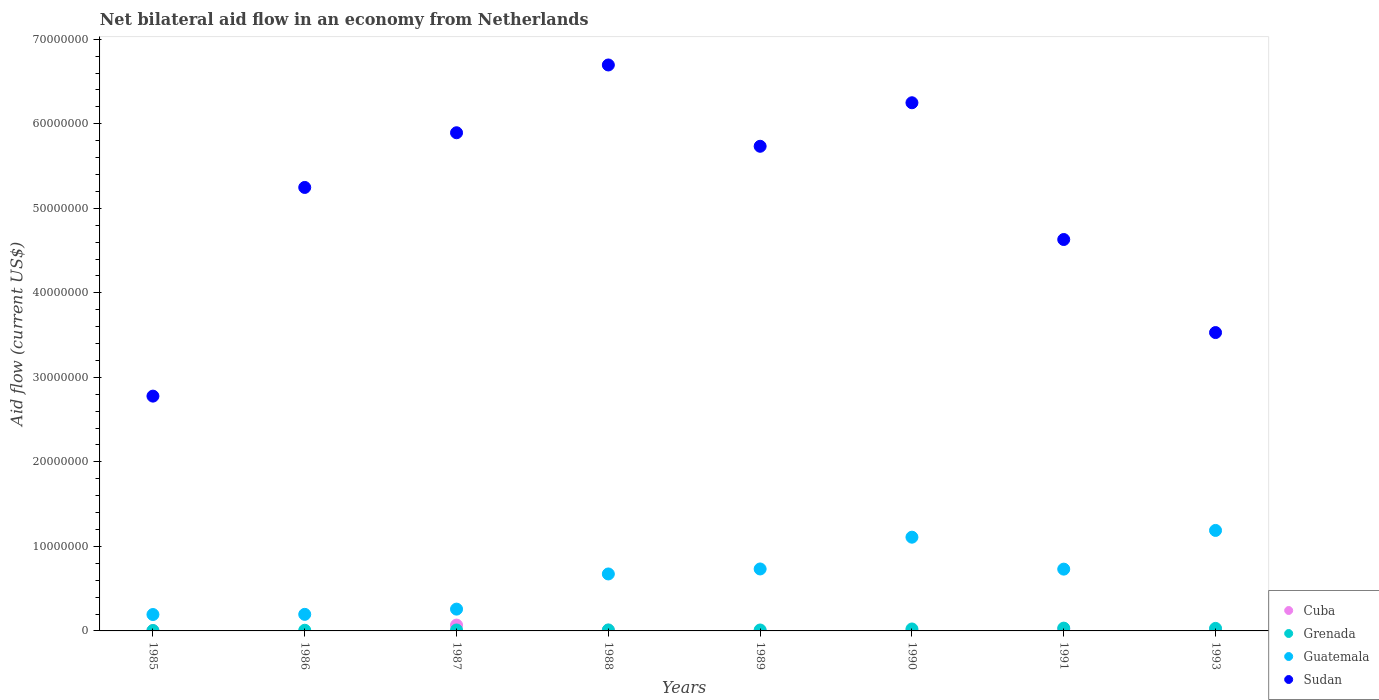How many different coloured dotlines are there?
Give a very brief answer. 4. Is the number of dotlines equal to the number of legend labels?
Give a very brief answer. No. What is the net bilateral aid flow in Guatemala in 1986?
Your answer should be compact. 1.96e+06. Across all years, what is the maximum net bilateral aid flow in Sudan?
Your answer should be very brief. 6.70e+07. What is the total net bilateral aid flow in Grenada in the graph?
Ensure brevity in your answer.  1.33e+06. What is the difference between the net bilateral aid flow in Cuba in 1985 and that in 1987?
Offer a terse response. -6.60e+05. What is the difference between the net bilateral aid flow in Sudan in 1993 and the net bilateral aid flow in Guatemala in 1986?
Offer a very short reply. 3.33e+07. What is the average net bilateral aid flow in Grenada per year?
Your response must be concise. 1.66e+05. In the year 1991, what is the difference between the net bilateral aid flow in Guatemala and net bilateral aid flow in Grenada?
Keep it short and to the point. 6.98e+06. In how many years, is the net bilateral aid flow in Sudan greater than 22000000 US$?
Provide a short and direct response. 8. What is the ratio of the net bilateral aid flow in Guatemala in 1985 to that in 1987?
Offer a terse response. 0.75. What is the difference between the highest and the second highest net bilateral aid flow in Cuba?
Make the answer very short. 4.70e+05. What is the difference between the highest and the lowest net bilateral aid flow in Guatemala?
Give a very brief answer. 9.95e+06. In how many years, is the net bilateral aid flow in Cuba greater than the average net bilateral aid flow in Cuba taken over all years?
Your response must be concise. 2. Is the net bilateral aid flow in Guatemala strictly greater than the net bilateral aid flow in Cuba over the years?
Provide a short and direct response. Yes. How many dotlines are there?
Offer a terse response. 4. What is the difference between two consecutive major ticks on the Y-axis?
Provide a short and direct response. 1.00e+07. Where does the legend appear in the graph?
Provide a short and direct response. Bottom right. What is the title of the graph?
Provide a succinct answer. Net bilateral aid flow in an economy from Netherlands. What is the Aid flow (current US$) of Grenada in 1985?
Your answer should be very brief. 5.00e+04. What is the Aid flow (current US$) of Guatemala in 1985?
Your response must be concise. 1.94e+06. What is the Aid flow (current US$) of Sudan in 1985?
Provide a short and direct response. 2.78e+07. What is the Aid flow (current US$) in Guatemala in 1986?
Your answer should be compact. 1.96e+06. What is the Aid flow (current US$) in Sudan in 1986?
Your answer should be very brief. 5.25e+07. What is the Aid flow (current US$) in Cuba in 1987?
Offer a very short reply. 6.90e+05. What is the Aid flow (current US$) of Guatemala in 1987?
Give a very brief answer. 2.58e+06. What is the Aid flow (current US$) in Sudan in 1987?
Offer a terse response. 5.89e+07. What is the Aid flow (current US$) of Cuba in 1988?
Give a very brief answer. 8.00e+04. What is the Aid flow (current US$) of Grenada in 1988?
Offer a very short reply. 1.20e+05. What is the Aid flow (current US$) of Guatemala in 1988?
Provide a succinct answer. 6.74e+06. What is the Aid flow (current US$) of Sudan in 1988?
Your answer should be compact. 6.70e+07. What is the Aid flow (current US$) of Guatemala in 1989?
Ensure brevity in your answer.  7.33e+06. What is the Aid flow (current US$) in Sudan in 1989?
Your answer should be compact. 5.73e+07. What is the Aid flow (current US$) in Grenada in 1990?
Provide a short and direct response. 2.30e+05. What is the Aid flow (current US$) in Guatemala in 1990?
Keep it short and to the point. 1.11e+07. What is the Aid flow (current US$) of Sudan in 1990?
Offer a terse response. 6.25e+07. What is the Aid flow (current US$) in Cuba in 1991?
Offer a very short reply. 2.20e+05. What is the Aid flow (current US$) in Grenada in 1991?
Make the answer very short. 3.30e+05. What is the Aid flow (current US$) in Guatemala in 1991?
Your response must be concise. 7.31e+06. What is the Aid flow (current US$) in Sudan in 1991?
Provide a succinct answer. 4.63e+07. What is the Aid flow (current US$) of Cuba in 1993?
Give a very brief answer. 1.10e+05. What is the Aid flow (current US$) in Grenada in 1993?
Give a very brief answer. 3.00e+05. What is the Aid flow (current US$) in Guatemala in 1993?
Provide a succinct answer. 1.19e+07. What is the Aid flow (current US$) in Sudan in 1993?
Provide a short and direct response. 3.53e+07. Across all years, what is the maximum Aid flow (current US$) of Cuba?
Make the answer very short. 6.90e+05. Across all years, what is the maximum Aid flow (current US$) in Guatemala?
Provide a short and direct response. 1.19e+07. Across all years, what is the maximum Aid flow (current US$) in Sudan?
Offer a very short reply. 6.70e+07. Across all years, what is the minimum Aid flow (current US$) of Guatemala?
Give a very brief answer. 1.94e+06. Across all years, what is the minimum Aid flow (current US$) of Sudan?
Offer a terse response. 2.78e+07. What is the total Aid flow (current US$) in Cuba in the graph?
Make the answer very short. 1.16e+06. What is the total Aid flow (current US$) in Grenada in the graph?
Give a very brief answer. 1.33e+06. What is the total Aid flow (current US$) in Guatemala in the graph?
Provide a succinct answer. 5.08e+07. What is the total Aid flow (current US$) of Sudan in the graph?
Your response must be concise. 4.08e+08. What is the difference between the Aid flow (current US$) in Grenada in 1985 and that in 1986?
Your answer should be very brief. -3.00e+04. What is the difference between the Aid flow (current US$) of Guatemala in 1985 and that in 1986?
Your answer should be compact. -2.00e+04. What is the difference between the Aid flow (current US$) of Sudan in 1985 and that in 1986?
Give a very brief answer. -2.47e+07. What is the difference between the Aid flow (current US$) of Cuba in 1985 and that in 1987?
Your response must be concise. -6.60e+05. What is the difference between the Aid flow (current US$) of Grenada in 1985 and that in 1987?
Provide a succinct answer. -6.00e+04. What is the difference between the Aid flow (current US$) in Guatemala in 1985 and that in 1987?
Give a very brief answer. -6.40e+05. What is the difference between the Aid flow (current US$) in Sudan in 1985 and that in 1987?
Your response must be concise. -3.12e+07. What is the difference between the Aid flow (current US$) of Cuba in 1985 and that in 1988?
Ensure brevity in your answer.  -5.00e+04. What is the difference between the Aid flow (current US$) in Guatemala in 1985 and that in 1988?
Keep it short and to the point. -4.80e+06. What is the difference between the Aid flow (current US$) in Sudan in 1985 and that in 1988?
Give a very brief answer. -3.92e+07. What is the difference between the Aid flow (current US$) in Guatemala in 1985 and that in 1989?
Your answer should be compact. -5.39e+06. What is the difference between the Aid flow (current US$) in Sudan in 1985 and that in 1989?
Keep it short and to the point. -2.96e+07. What is the difference between the Aid flow (current US$) of Cuba in 1985 and that in 1990?
Your answer should be very brief. 2.00e+04. What is the difference between the Aid flow (current US$) in Guatemala in 1985 and that in 1990?
Keep it short and to the point. -9.15e+06. What is the difference between the Aid flow (current US$) of Sudan in 1985 and that in 1990?
Provide a succinct answer. -3.47e+07. What is the difference between the Aid flow (current US$) of Cuba in 1985 and that in 1991?
Make the answer very short. -1.90e+05. What is the difference between the Aid flow (current US$) of Grenada in 1985 and that in 1991?
Offer a very short reply. -2.80e+05. What is the difference between the Aid flow (current US$) in Guatemala in 1985 and that in 1991?
Offer a terse response. -5.37e+06. What is the difference between the Aid flow (current US$) of Sudan in 1985 and that in 1991?
Your answer should be very brief. -1.85e+07. What is the difference between the Aid flow (current US$) of Cuba in 1985 and that in 1993?
Make the answer very short. -8.00e+04. What is the difference between the Aid flow (current US$) of Guatemala in 1985 and that in 1993?
Give a very brief answer. -9.95e+06. What is the difference between the Aid flow (current US$) in Sudan in 1985 and that in 1993?
Ensure brevity in your answer.  -7.52e+06. What is the difference between the Aid flow (current US$) in Guatemala in 1986 and that in 1987?
Give a very brief answer. -6.20e+05. What is the difference between the Aid flow (current US$) of Sudan in 1986 and that in 1987?
Offer a terse response. -6.47e+06. What is the difference between the Aid flow (current US$) of Guatemala in 1986 and that in 1988?
Offer a terse response. -4.78e+06. What is the difference between the Aid flow (current US$) in Sudan in 1986 and that in 1988?
Make the answer very short. -1.45e+07. What is the difference between the Aid flow (current US$) of Grenada in 1986 and that in 1989?
Give a very brief answer. -3.00e+04. What is the difference between the Aid flow (current US$) in Guatemala in 1986 and that in 1989?
Your response must be concise. -5.37e+06. What is the difference between the Aid flow (current US$) of Sudan in 1986 and that in 1989?
Your response must be concise. -4.87e+06. What is the difference between the Aid flow (current US$) of Guatemala in 1986 and that in 1990?
Keep it short and to the point. -9.13e+06. What is the difference between the Aid flow (current US$) in Sudan in 1986 and that in 1990?
Offer a very short reply. -1.00e+07. What is the difference between the Aid flow (current US$) of Guatemala in 1986 and that in 1991?
Make the answer very short. -5.35e+06. What is the difference between the Aid flow (current US$) in Sudan in 1986 and that in 1991?
Offer a terse response. 6.16e+06. What is the difference between the Aid flow (current US$) in Grenada in 1986 and that in 1993?
Your answer should be compact. -2.20e+05. What is the difference between the Aid flow (current US$) of Guatemala in 1986 and that in 1993?
Your answer should be compact. -9.93e+06. What is the difference between the Aid flow (current US$) in Sudan in 1986 and that in 1993?
Provide a succinct answer. 1.72e+07. What is the difference between the Aid flow (current US$) of Cuba in 1987 and that in 1988?
Offer a very short reply. 6.10e+05. What is the difference between the Aid flow (current US$) of Grenada in 1987 and that in 1988?
Offer a terse response. -10000. What is the difference between the Aid flow (current US$) in Guatemala in 1987 and that in 1988?
Ensure brevity in your answer.  -4.16e+06. What is the difference between the Aid flow (current US$) in Sudan in 1987 and that in 1988?
Your answer should be compact. -8.02e+06. What is the difference between the Aid flow (current US$) of Cuba in 1987 and that in 1989?
Your answer should be compact. 6.70e+05. What is the difference between the Aid flow (current US$) in Guatemala in 1987 and that in 1989?
Provide a short and direct response. -4.75e+06. What is the difference between the Aid flow (current US$) of Sudan in 1987 and that in 1989?
Offer a very short reply. 1.60e+06. What is the difference between the Aid flow (current US$) in Cuba in 1987 and that in 1990?
Offer a terse response. 6.80e+05. What is the difference between the Aid flow (current US$) in Grenada in 1987 and that in 1990?
Offer a very short reply. -1.20e+05. What is the difference between the Aid flow (current US$) of Guatemala in 1987 and that in 1990?
Keep it short and to the point. -8.51e+06. What is the difference between the Aid flow (current US$) of Sudan in 1987 and that in 1990?
Offer a very short reply. -3.55e+06. What is the difference between the Aid flow (current US$) of Cuba in 1987 and that in 1991?
Your response must be concise. 4.70e+05. What is the difference between the Aid flow (current US$) in Grenada in 1987 and that in 1991?
Make the answer very short. -2.20e+05. What is the difference between the Aid flow (current US$) of Guatemala in 1987 and that in 1991?
Keep it short and to the point. -4.73e+06. What is the difference between the Aid flow (current US$) in Sudan in 1987 and that in 1991?
Your answer should be compact. 1.26e+07. What is the difference between the Aid flow (current US$) of Cuba in 1987 and that in 1993?
Ensure brevity in your answer.  5.80e+05. What is the difference between the Aid flow (current US$) of Guatemala in 1987 and that in 1993?
Provide a succinct answer. -9.31e+06. What is the difference between the Aid flow (current US$) of Sudan in 1987 and that in 1993?
Offer a very short reply. 2.36e+07. What is the difference between the Aid flow (current US$) of Cuba in 1988 and that in 1989?
Provide a succinct answer. 6.00e+04. What is the difference between the Aid flow (current US$) in Guatemala in 1988 and that in 1989?
Ensure brevity in your answer.  -5.90e+05. What is the difference between the Aid flow (current US$) in Sudan in 1988 and that in 1989?
Keep it short and to the point. 9.62e+06. What is the difference between the Aid flow (current US$) of Grenada in 1988 and that in 1990?
Your answer should be compact. -1.10e+05. What is the difference between the Aid flow (current US$) in Guatemala in 1988 and that in 1990?
Provide a short and direct response. -4.35e+06. What is the difference between the Aid flow (current US$) of Sudan in 1988 and that in 1990?
Provide a succinct answer. 4.47e+06. What is the difference between the Aid flow (current US$) in Cuba in 1988 and that in 1991?
Ensure brevity in your answer.  -1.40e+05. What is the difference between the Aid flow (current US$) of Grenada in 1988 and that in 1991?
Your response must be concise. -2.10e+05. What is the difference between the Aid flow (current US$) in Guatemala in 1988 and that in 1991?
Your answer should be very brief. -5.70e+05. What is the difference between the Aid flow (current US$) of Sudan in 1988 and that in 1991?
Give a very brief answer. 2.06e+07. What is the difference between the Aid flow (current US$) of Guatemala in 1988 and that in 1993?
Your answer should be compact. -5.15e+06. What is the difference between the Aid flow (current US$) of Sudan in 1988 and that in 1993?
Provide a short and direct response. 3.17e+07. What is the difference between the Aid flow (current US$) in Cuba in 1989 and that in 1990?
Keep it short and to the point. 10000. What is the difference between the Aid flow (current US$) in Guatemala in 1989 and that in 1990?
Your response must be concise. -3.76e+06. What is the difference between the Aid flow (current US$) of Sudan in 1989 and that in 1990?
Your answer should be very brief. -5.15e+06. What is the difference between the Aid flow (current US$) of Sudan in 1989 and that in 1991?
Offer a very short reply. 1.10e+07. What is the difference between the Aid flow (current US$) of Guatemala in 1989 and that in 1993?
Your response must be concise. -4.56e+06. What is the difference between the Aid flow (current US$) in Sudan in 1989 and that in 1993?
Give a very brief answer. 2.20e+07. What is the difference between the Aid flow (current US$) in Cuba in 1990 and that in 1991?
Ensure brevity in your answer.  -2.10e+05. What is the difference between the Aid flow (current US$) of Grenada in 1990 and that in 1991?
Offer a terse response. -1.00e+05. What is the difference between the Aid flow (current US$) in Guatemala in 1990 and that in 1991?
Give a very brief answer. 3.78e+06. What is the difference between the Aid flow (current US$) of Sudan in 1990 and that in 1991?
Offer a very short reply. 1.62e+07. What is the difference between the Aid flow (current US$) in Cuba in 1990 and that in 1993?
Provide a short and direct response. -1.00e+05. What is the difference between the Aid flow (current US$) in Grenada in 1990 and that in 1993?
Give a very brief answer. -7.00e+04. What is the difference between the Aid flow (current US$) of Guatemala in 1990 and that in 1993?
Offer a very short reply. -8.00e+05. What is the difference between the Aid flow (current US$) of Sudan in 1990 and that in 1993?
Offer a terse response. 2.72e+07. What is the difference between the Aid flow (current US$) in Cuba in 1991 and that in 1993?
Keep it short and to the point. 1.10e+05. What is the difference between the Aid flow (current US$) in Grenada in 1991 and that in 1993?
Provide a short and direct response. 3.00e+04. What is the difference between the Aid flow (current US$) in Guatemala in 1991 and that in 1993?
Keep it short and to the point. -4.58e+06. What is the difference between the Aid flow (current US$) of Sudan in 1991 and that in 1993?
Offer a very short reply. 1.10e+07. What is the difference between the Aid flow (current US$) in Cuba in 1985 and the Aid flow (current US$) in Guatemala in 1986?
Offer a terse response. -1.93e+06. What is the difference between the Aid flow (current US$) in Cuba in 1985 and the Aid flow (current US$) in Sudan in 1986?
Your answer should be compact. -5.24e+07. What is the difference between the Aid flow (current US$) in Grenada in 1985 and the Aid flow (current US$) in Guatemala in 1986?
Your answer should be very brief. -1.91e+06. What is the difference between the Aid flow (current US$) of Grenada in 1985 and the Aid flow (current US$) of Sudan in 1986?
Your answer should be very brief. -5.24e+07. What is the difference between the Aid flow (current US$) in Guatemala in 1985 and the Aid flow (current US$) in Sudan in 1986?
Provide a succinct answer. -5.05e+07. What is the difference between the Aid flow (current US$) in Cuba in 1985 and the Aid flow (current US$) in Grenada in 1987?
Provide a succinct answer. -8.00e+04. What is the difference between the Aid flow (current US$) in Cuba in 1985 and the Aid flow (current US$) in Guatemala in 1987?
Keep it short and to the point. -2.55e+06. What is the difference between the Aid flow (current US$) in Cuba in 1985 and the Aid flow (current US$) in Sudan in 1987?
Provide a short and direct response. -5.89e+07. What is the difference between the Aid flow (current US$) in Grenada in 1985 and the Aid flow (current US$) in Guatemala in 1987?
Keep it short and to the point. -2.53e+06. What is the difference between the Aid flow (current US$) in Grenada in 1985 and the Aid flow (current US$) in Sudan in 1987?
Provide a short and direct response. -5.89e+07. What is the difference between the Aid flow (current US$) of Guatemala in 1985 and the Aid flow (current US$) of Sudan in 1987?
Offer a terse response. -5.70e+07. What is the difference between the Aid flow (current US$) in Cuba in 1985 and the Aid flow (current US$) in Grenada in 1988?
Give a very brief answer. -9.00e+04. What is the difference between the Aid flow (current US$) of Cuba in 1985 and the Aid flow (current US$) of Guatemala in 1988?
Make the answer very short. -6.71e+06. What is the difference between the Aid flow (current US$) of Cuba in 1985 and the Aid flow (current US$) of Sudan in 1988?
Ensure brevity in your answer.  -6.69e+07. What is the difference between the Aid flow (current US$) of Grenada in 1985 and the Aid flow (current US$) of Guatemala in 1988?
Your answer should be very brief. -6.69e+06. What is the difference between the Aid flow (current US$) of Grenada in 1985 and the Aid flow (current US$) of Sudan in 1988?
Your answer should be compact. -6.69e+07. What is the difference between the Aid flow (current US$) of Guatemala in 1985 and the Aid flow (current US$) of Sudan in 1988?
Your answer should be very brief. -6.50e+07. What is the difference between the Aid flow (current US$) in Cuba in 1985 and the Aid flow (current US$) in Grenada in 1989?
Provide a short and direct response. -8.00e+04. What is the difference between the Aid flow (current US$) in Cuba in 1985 and the Aid flow (current US$) in Guatemala in 1989?
Your answer should be compact. -7.30e+06. What is the difference between the Aid flow (current US$) in Cuba in 1985 and the Aid flow (current US$) in Sudan in 1989?
Your answer should be very brief. -5.73e+07. What is the difference between the Aid flow (current US$) in Grenada in 1985 and the Aid flow (current US$) in Guatemala in 1989?
Ensure brevity in your answer.  -7.28e+06. What is the difference between the Aid flow (current US$) in Grenada in 1985 and the Aid flow (current US$) in Sudan in 1989?
Ensure brevity in your answer.  -5.73e+07. What is the difference between the Aid flow (current US$) in Guatemala in 1985 and the Aid flow (current US$) in Sudan in 1989?
Your response must be concise. -5.54e+07. What is the difference between the Aid flow (current US$) of Cuba in 1985 and the Aid flow (current US$) of Grenada in 1990?
Provide a short and direct response. -2.00e+05. What is the difference between the Aid flow (current US$) of Cuba in 1985 and the Aid flow (current US$) of Guatemala in 1990?
Keep it short and to the point. -1.11e+07. What is the difference between the Aid flow (current US$) of Cuba in 1985 and the Aid flow (current US$) of Sudan in 1990?
Provide a short and direct response. -6.25e+07. What is the difference between the Aid flow (current US$) in Grenada in 1985 and the Aid flow (current US$) in Guatemala in 1990?
Provide a short and direct response. -1.10e+07. What is the difference between the Aid flow (current US$) in Grenada in 1985 and the Aid flow (current US$) in Sudan in 1990?
Your answer should be compact. -6.24e+07. What is the difference between the Aid flow (current US$) of Guatemala in 1985 and the Aid flow (current US$) of Sudan in 1990?
Provide a short and direct response. -6.06e+07. What is the difference between the Aid flow (current US$) of Cuba in 1985 and the Aid flow (current US$) of Guatemala in 1991?
Offer a very short reply. -7.28e+06. What is the difference between the Aid flow (current US$) in Cuba in 1985 and the Aid flow (current US$) in Sudan in 1991?
Offer a terse response. -4.63e+07. What is the difference between the Aid flow (current US$) in Grenada in 1985 and the Aid flow (current US$) in Guatemala in 1991?
Your answer should be compact. -7.26e+06. What is the difference between the Aid flow (current US$) in Grenada in 1985 and the Aid flow (current US$) in Sudan in 1991?
Ensure brevity in your answer.  -4.63e+07. What is the difference between the Aid flow (current US$) in Guatemala in 1985 and the Aid flow (current US$) in Sudan in 1991?
Keep it short and to the point. -4.44e+07. What is the difference between the Aid flow (current US$) of Cuba in 1985 and the Aid flow (current US$) of Grenada in 1993?
Offer a very short reply. -2.70e+05. What is the difference between the Aid flow (current US$) in Cuba in 1985 and the Aid flow (current US$) in Guatemala in 1993?
Offer a terse response. -1.19e+07. What is the difference between the Aid flow (current US$) of Cuba in 1985 and the Aid flow (current US$) of Sudan in 1993?
Keep it short and to the point. -3.53e+07. What is the difference between the Aid flow (current US$) of Grenada in 1985 and the Aid flow (current US$) of Guatemala in 1993?
Your response must be concise. -1.18e+07. What is the difference between the Aid flow (current US$) in Grenada in 1985 and the Aid flow (current US$) in Sudan in 1993?
Your response must be concise. -3.52e+07. What is the difference between the Aid flow (current US$) of Guatemala in 1985 and the Aid flow (current US$) of Sudan in 1993?
Give a very brief answer. -3.34e+07. What is the difference between the Aid flow (current US$) in Grenada in 1986 and the Aid flow (current US$) in Guatemala in 1987?
Your answer should be very brief. -2.50e+06. What is the difference between the Aid flow (current US$) of Grenada in 1986 and the Aid flow (current US$) of Sudan in 1987?
Offer a terse response. -5.89e+07. What is the difference between the Aid flow (current US$) in Guatemala in 1986 and the Aid flow (current US$) in Sudan in 1987?
Your answer should be very brief. -5.70e+07. What is the difference between the Aid flow (current US$) in Grenada in 1986 and the Aid flow (current US$) in Guatemala in 1988?
Provide a succinct answer. -6.66e+06. What is the difference between the Aid flow (current US$) of Grenada in 1986 and the Aid flow (current US$) of Sudan in 1988?
Provide a short and direct response. -6.69e+07. What is the difference between the Aid flow (current US$) in Guatemala in 1986 and the Aid flow (current US$) in Sudan in 1988?
Offer a terse response. -6.50e+07. What is the difference between the Aid flow (current US$) of Grenada in 1986 and the Aid flow (current US$) of Guatemala in 1989?
Ensure brevity in your answer.  -7.25e+06. What is the difference between the Aid flow (current US$) of Grenada in 1986 and the Aid flow (current US$) of Sudan in 1989?
Keep it short and to the point. -5.73e+07. What is the difference between the Aid flow (current US$) in Guatemala in 1986 and the Aid flow (current US$) in Sudan in 1989?
Ensure brevity in your answer.  -5.54e+07. What is the difference between the Aid flow (current US$) of Grenada in 1986 and the Aid flow (current US$) of Guatemala in 1990?
Ensure brevity in your answer.  -1.10e+07. What is the difference between the Aid flow (current US$) of Grenada in 1986 and the Aid flow (current US$) of Sudan in 1990?
Provide a succinct answer. -6.24e+07. What is the difference between the Aid flow (current US$) of Guatemala in 1986 and the Aid flow (current US$) of Sudan in 1990?
Provide a short and direct response. -6.05e+07. What is the difference between the Aid flow (current US$) of Grenada in 1986 and the Aid flow (current US$) of Guatemala in 1991?
Your response must be concise. -7.23e+06. What is the difference between the Aid flow (current US$) of Grenada in 1986 and the Aid flow (current US$) of Sudan in 1991?
Provide a succinct answer. -4.62e+07. What is the difference between the Aid flow (current US$) in Guatemala in 1986 and the Aid flow (current US$) in Sudan in 1991?
Keep it short and to the point. -4.44e+07. What is the difference between the Aid flow (current US$) in Grenada in 1986 and the Aid flow (current US$) in Guatemala in 1993?
Offer a terse response. -1.18e+07. What is the difference between the Aid flow (current US$) in Grenada in 1986 and the Aid flow (current US$) in Sudan in 1993?
Give a very brief answer. -3.52e+07. What is the difference between the Aid flow (current US$) in Guatemala in 1986 and the Aid flow (current US$) in Sudan in 1993?
Your answer should be very brief. -3.33e+07. What is the difference between the Aid flow (current US$) of Cuba in 1987 and the Aid flow (current US$) of Grenada in 1988?
Keep it short and to the point. 5.70e+05. What is the difference between the Aid flow (current US$) in Cuba in 1987 and the Aid flow (current US$) in Guatemala in 1988?
Offer a very short reply. -6.05e+06. What is the difference between the Aid flow (current US$) in Cuba in 1987 and the Aid flow (current US$) in Sudan in 1988?
Offer a very short reply. -6.63e+07. What is the difference between the Aid flow (current US$) in Grenada in 1987 and the Aid flow (current US$) in Guatemala in 1988?
Offer a terse response. -6.63e+06. What is the difference between the Aid flow (current US$) of Grenada in 1987 and the Aid flow (current US$) of Sudan in 1988?
Your response must be concise. -6.68e+07. What is the difference between the Aid flow (current US$) in Guatemala in 1987 and the Aid flow (current US$) in Sudan in 1988?
Your answer should be compact. -6.44e+07. What is the difference between the Aid flow (current US$) in Cuba in 1987 and the Aid flow (current US$) in Grenada in 1989?
Your response must be concise. 5.80e+05. What is the difference between the Aid flow (current US$) in Cuba in 1987 and the Aid flow (current US$) in Guatemala in 1989?
Ensure brevity in your answer.  -6.64e+06. What is the difference between the Aid flow (current US$) in Cuba in 1987 and the Aid flow (current US$) in Sudan in 1989?
Provide a short and direct response. -5.66e+07. What is the difference between the Aid flow (current US$) in Grenada in 1987 and the Aid flow (current US$) in Guatemala in 1989?
Provide a succinct answer. -7.22e+06. What is the difference between the Aid flow (current US$) in Grenada in 1987 and the Aid flow (current US$) in Sudan in 1989?
Provide a succinct answer. -5.72e+07. What is the difference between the Aid flow (current US$) in Guatemala in 1987 and the Aid flow (current US$) in Sudan in 1989?
Your answer should be compact. -5.48e+07. What is the difference between the Aid flow (current US$) in Cuba in 1987 and the Aid flow (current US$) in Grenada in 1990?
Keep it short and to the point. 4.60e+05. What is the difference between the Aid flow (current US$) of Cuba in 1987 and the Aid flow (current US$) of Guatemala in 1990?
Your response must be concise. -1.04e+07. What is the difference between the Aid flow (current US$) in Cuba in 1987 and the Aid flow (current US$) in Sudan in 1990?
Provide a succinct answer. -6.18e+07. What is the difference between the Aid flow (current US$) in Grenada in 1987 and the Aid flow (current US$) in Guatemala in 1990?
Ensure brevity in your answer.  -1.10e+07. What is the difference between the Aid flow (current US$) of Grenada in 1987 and the Aid flow (current US$) of Sudan in 1990?
Ensure brevity in your answer.  -6.24e+07. What is the difference between the Aid flow (current US$) of Guatemala in 1987 and the Aid flow (current US$) of Sudan in 1990?
Make the answer very short. -5.99e+07. What is the difference between the Aid flow (current US$) of Cuba in 1987 and the Aid flow (current US$) of Grenada in 1991?
Provide a succinct answer. 3.60e+05. What is the difference between the Aid flow (current US$) of Cuba in 1987 and the Aid flow (current US$) of Guatemala in 1991?
Offer a very short reply. -6.62e+06. What is the difference between the Aid flow (current US$) in Cuba in 1987 and the Aid flow (current US$) in Sudan in 1991?
Give a very brief answer. -4.56e+07. What is the difference between the Aid flow (current US$) in Grenada in 1987 and the Aid flow (current US$) in Guatemala in 1991?
Give a very brief answer. -7.20e+06. What is the difference between the Aid flow (current US$) of Grenada in 1987 and the Aid flow (current US$) of Sudan in 1991?
Provide a succinct answer. -4.62e+07. What is the difference between the Aid flow (current US$) in Guatemala in 1987 and the Aid flow (current US$) in Sudan in 1991?
Your answer should be very brief. -4.37e+07. What is the difference between the Aid flow (current US$) in Cuba in 1987 and the Aid flow (current US$) in Guatemala in 1993?
Offer a terse response. -1.12e+07. What is the difference between the Aid flow (current US$) of Cuba in 1987 and the Aid flow (current US$) of Sudan in 1993?
Make the answer very short. -3.46e+07. What is the difference between the Aid flow (current US$) in Grenada in 1987 and the Aid flow (current US$) in Guatemala in 1993?
Offer a terse response. -1.18e+07. What is the difference between the Aid flow (current US$) in Grenada in 1987 and the Aid flow (current US$) in Sudan in 1993?
Provide a succinct answer. -3.52e+07. What is the difference between the Aid flow (current US$) in Guatemala in 1987 and the Aid flow (current US$) in Sudan in 1993?
Give a very brief answer. -3.27e+07. What is the difference between the Aid flow (current US$) in Cuba in 1988 and the Aid flow (current US$) in Guatemala in 1989?
Provide a succinct answer. -7.25e+06. What is the difference between the Aid flow (current US$) of Cuba in 1988 and the Aid flow (current US$) of Sudan in 1989?
Keep it short and to the point. -5.73e+07. What is the difference between the Aid flow (current US$) in Grenada in 1988 and the Aid flow (current US$) in Guatemala in 1989?
Ensure brevity in your answer.  -7.21e+06. What is the difference between the Aid flow (current US$) of Grenada in 1988 and the Aid flow (current US$) of Sudan in 1989?
Keep it short and to the point. -5.72e+07. What is the difference between the Aid flow (current US$) in Guatemala in 1988 and the Aid flow (current US$) in Sudan in 1989?
Make the answer very short. -5.06e+07. What is the difference between the Aid flow (current US$) of Cuba in 1988 and the Aid flow (current US$) of Guatemala in 1990?
Your answer should be compact. -1.10e+07. What is the difference between the Aid flow (current US$) of Cuba in 1988 and the Aid flow (current US$) of Sudan in 1990?
Offer a terse response. -6.24e+07. What is the difference between the Aid flow (current US$) of Grenada in 1988 and the Aid flow (current US$) of Guatemala in 1990?
Make the answer very short. -1.10e+07. What is the difference between the Aid flow (current US$) of Grenada in 1988 and the Aid flow (current US$) of Sudan in 1990?
Provide a short and direct response. -6.24e+07. What is the difference between the Aid flow (current US$) in Guatemala in 1988 and the Aid flow (current US$) in Sudan in 1990?
Provide a short and direct response. -5.58e+07. What is the difference between the Aid flow (current US$) of Cuba in 1988 and the Aid flow (current US$) of Guatemala in 1991?
Ensure brevity in your answer.  -7.23e+06. What is the difference between the Aid flow (current US$) in Cuba in 1988 and the Aid flow (current US$) in Sudan in 1991?
Ensure brevity in your answer.  -4.62e+07. What is the difference between the Aid flow (current US$) in Grenada in 1988 and the Aid flow (current US$) in Guatemala in 1991?
Offer a terse response. -7.19e+06. What is the difference between the Aid flow (current US$) of Grenada in 1988 and the Aid flow (current US$) of Sudan in 1991?
Offer a very short reply. -4.62e+07. What is the difference between the Aid flow (current US$) in Guatemala in 1988 and the Aid flow (current US$) in Sudan in 1991?
Provide a short and direct response. -3.96e+07. What is the difference between the Aid flow (current US$) in Cuba in 1988 and the Aid flow (current US$) in Grenada in 1993?
Offer a very short reply. -2.20e+05. What is the difference between the Aid flow (current US$) of Cuba in 1988 and the Aid flow (current US$) of Guatemala in 1993?
Your response must be concise. -1.18e+07. What is the difference between the Aid flow (current US$) of Cuba in 1988 and the Aid flow (current US$) of Sudan in 1993?
Your response must be concise. -3.52e+07. What is the difference between the Aid flow (current US$) of Grenada in 1988 and the Aid flow (current US$) of Guatemala in 1993?
Offer a very short reply. -1.18e+07. What is the difference between the Aid flow (current US$) of Grenada in 1988 and the Aid flow (current US$) of Sudan in 1993?
Keep it short and to the point. -3.52e+07. What is the difference between the Aid flow (current US$) in Guatemala in 1988 and the Aid flow (current US$) in Sudan in 1993?
Give a very brief answer. -2.86e+07. What is the difference between the Aid flow (current US$) in Cuba in 1989 and the Aid flow (current US$) in Grenada in 1990?
Give a very brief answer. -2.10e+05. What is the difference between the Aid flow (current US$) of Cuba in 1989 and the Aid flow (current US$) of Guatemala in 1990?
Ensure brevity in your answer.  -1.11e+07. What is the difference between the Aid flow (current US$) of Cuba in 1989 and the Aid flow (current US$) of Sudan in 1990?
Your response must be concise. -6.25e+07. What is the difference between the Aid flow (current US$) of Grenada in 1989 and the Aid flow (current US$) of Guatemala in 1990?
Your answer should be very brief. -1.10e+07. What is the difference between the Aid flow (current US$) in Grenada in 1989 and the Aid flow (current US$) in Sudan in 1990?
Provide a succinct answer. -6.24e+07. What is the difference between the Aid flow (current US$) in Guatemala in 1989 and the Aid flow (current US$) in Sudan in 1990?
Your response must be concise. -5.52e+07. What is the difference between the Aid flow (current US$) of Cuba in 1989 and the Aid flow (current US$) of Grenada in 1991?
Your response must be concise. -3.10e+05. What is the difference between the Aid flow (current US$) of Cuba in 1989 and the Aid flow (current US$) of Guatemala in 1991?
Give a very brief answer. -7.29e+06. What is the difference between the Aid flow (current US$) in Cuba in 1989 and the Aid flow (current US$) in Sudan in 1991?
Provide a short and direct response. -4.63e+07. What is the difference between the Aid flow (current US$) in Grenada in 1989 and the Aid flow (current US$) in Guatemala in 1991?
Make the answer very short. -7.20e+06. What is the difference between the Aid flow (current US$) of Grenada in 1989 and the Aid flow (current US$) of Sudan in 1991?
Ensure brevity in your answer.  -4.62e+07. What is the difference between the Aid flow (current US$) in Guatemala in 1989 and the Aid flow (current US$) in Sudan in 1991?
Your answer should be very brief. -3.90e+07. What is the difference between the Aid flow (current US$) in Cuba in 1989 and the Aid flow (current US$) in Grenada in 1993?
Give a very brief answer. -2.80e+05. What is the difference between the Aid flow (current US$) of Cuba in 1989 and the Aid flow (current US$) of Guatemala in 1993?
Give a very brief answer. -1.19e+07. What is the difference between the Aid flow (current US$) of Cuba in 1989 and the Aid flow (current US$) of Sudan in 1993?
Offer a very short reply. -3.53e+07. What is the difference between the Aid flow (current US$) in Grenada in 1989 and the Aid flow (current US$) in Guatemala in 1993?
Ensure brevity in your answer.  -1.18e+07. What is the difference between the Aid flow (current US$) in Grenada in 1989 and the Aid flow (current US$) in Sudan in 1993?
Provide a short and direct response. -3.52e+07. What is the difference between the Aid flow (current US$) of Guatemala in 1989 and the Aid flow (current US$) of Sudan in 1993?
Keep it short and to the point. -2.80e+07. What is the difference between the Aid flow (current US$) of Cuba in 1990 and the Aid flow (current US$) of Grenada in 1991?
Ensure brevity in your answer.  -3.20e+05. What is the difference between the Aid flow (current US$) in Cuba in 1990 and the Aid flow (current US$) in Guatemala in 1991?
Keep it short and to the point. -7.30e+06. What is the difference between the Aid flow (current US$) of Cuba in 1990 and the Aid flow (current US$) of Sudan in 1991?
Offer a very short reply. -4.63e+07. What is the difference between the Aid flow (current US$) of Grenada in 1990 and the Aid flow (current US$) of Guatemala in 1991?
Your response must be concise. -7.08e+06. What is the difference between the Aid flow (current US$) of Grenada in 1990 and the Aid flow (current US$) of Sudan in 1991?
Your response must be concise. -4.61e+07. What is the difference between the Aid flow (current US$) in Guatemala in 1990 and the Aid flow (current US$) in Sudan in 1991?
Provide a short and direct response. -3.52e+07. What is the difference between the Aid flow (current US$) of Cuba in 1990 and the Aid flow (current US$) of Grenada in 1993?
Offer a very short reply. -2.90e+05. What is the difference between the Aid flow (current US$) of Cuba in 1990 and the Aid flow (current US$) of Guatemala in 1993?
Offer a very short reply. -1.19e+07. What is the difference between the Aid flow (current US$) of Cuba in 1990 and the Aid flow (current US$) of Sudan in 1993?
Keep it short and to the point. -3.53e+07. What is the difference between the Aid flow (current US$) in Grenada in 1990 and the Aid flow (current US$) in Guatemala in 1993?
Ensure brevity in your answer.  -1.17e+07. What is the difference between the Aid flow (current US$) in Grenada in 1990 and the Aid flow (current US$) in Sudan in 1993?
Give a very brief answer. -3.51e+07. What is the difference between the Aid flow (current US$) of Guatemala in 1990 and the Aid flow (current US$) of Sudan in 1993?
Your answer should be compact. -2.42e+07. What is the difference between the Aid flow (current US$) of Cuba in 1991 and the Aid flow (current US$) of Grenada in 1993?
Keep it short and to the point. -8.00e+04. What is the difference between the Aid flow (current US$) of Cuba in 1991 and the Aid flow (current US$) of Guatemala in 1993?
Make the answer very short. -1.17e+07. What is the difference between the Aid flow (current US$) in Cuba in 1991 and the Aid flow (current US$) in Sudan in 1993?
Ensure brevity in your answer.  -3.51e+07. What is the difference between the Aid flow (current US$) in Grenada in 1991 and the Aid flow (current US$) in Guatemala in 1993?
Provide a succinct answer. -1.16e+07. What is the difference between the Aid flow (current US$) of Grenada in 1991 and the Aid flow (current US$) of Sudan in 1993?
Make the answer very short. -3.50e+07. What is the difference between the Aid flow (current US$) of Guatemala in 1991 and the Aid flow (current US$) of Sudan in 1993?
Provide a short and direct response. -2.80e+07. What is the average Aid flow (current US$) in Cuba per year?
Give a very brief answer. 1.45e+05. What is the average Aid flow (current US$) in Grenada per year?
Provide a succinct answer. 1.66e+05. What is the average Aid flow (current US$) in Guatemala per year?
Your response must be concise. 6.36e+06. What is the average Aid flow (current US$) of Sudan per year?
Provide a succinct answer. 5.09e+07. In the year 1985, what is the difference between the Aid flow (current US$) of Cuba and Aid flow (current US$) of Grenada?
Your answer should be compact. -2.00e+04. In the year 1985, what is the difference between the Aid flow (current US$) of Cuba and Aid flow (current US$) of Guatemala?
Your response must be concise. -1.91e+06. In the year 1985, what is the difference between the Aid flow (current US$) in Cuba and Aid flow (current US$) in Sudan?
Provide a succinct answer. -2.78e+07. In the year 1985, what is the difference between the Aid flow (current US$) of Grenada and Aid flow (current US$) of Guatemala?
Offer a terse response. -1.89e+06. In the year 1985, what is the difference between the Aid flow (current US$) of Grenada and Aid flow (current US$) of Sudan?
Offer a terse response. -2.77e+07. In the year 1985, what is the difference between the Aid flow (current US$) of Guatemala and Aid flow (current US$) of Sudan?
Give a very brief answer. -2.58e+07. In the year 1986, what is the difference between the Aid flow (current US$) of Grenada and Aid flow (current US$) of Guatemala?
Offer a very short reply. -1.88e+06. In the year 1986, what is the difference between the Aid flow (current US$) of Grenada and Aid flow (current US$) of Sudan?
Ensure brevity in your answer.  -5.24e+07. In the year 1986, what is the difference between the Aid flow (current US$) in Guatemala and Aid flow (current US$) in Sudan?
Offer a terse response. -5.05e+07. In the year 1987, what is the difference between the Aid flow (current US$) in Cuba and Aid flow (current US$) in Grenada?
Give a very brief answer. 5.80e+05. In the year 1987, what is the difference between the Aid flow (current US$) of Cuba and Aid flow (current US$) of Guatemala?
Keep it short and to the point. -1.89e+06. In the year 1987, what is the difference between the Aid flow (current US$) of Cuba and Aid flow (current US$) of Sudan?
Your answer should be compact. -5.82e+07. In the year 1987, what is the difference between the Aid flow (current US$) in Grenada and Aid flow (current US$) in Guatemala?
Your answer should be compact. -2.47e+06. In the year 1987, what is the difference between the Aid flow (current US$) in Grenada and Aid flow (current US$) in Sudan?
Provide a succinct answer. -5.88e+07. In the year 1987, what is the difference between the Aid flow (current US$) of Guatemala and Aid flow (current US$) of Sudan?
Give a very brief answer. -5.64e+07. In the year 1988, what is the difference between the Aid flow (current US$) in Cuba and Aid flow (current US$) in Guatemala?
Offer a terse response. -6.66e+06. In the year 1988, what is the difference between the Aid flow (current US$) of Cuba and Aid flow (current US$) of Sudan?
Your response must be concise. -6.69e+07. In the year 1988, what is the difference between the Aid flow (current US$) of Grenada and Aid flow (current US$) of Guatemala?
Provide a short and direct response. -6.62e+06. In the year 1988, what is the difference between the Aid flow (current US$) in Grenada and Aid flow (current US$) in Sudan?
Provide a succinct answer. -6.68e+07. In the year 1988, what is the difference between the Aid flow (current US$) of Guatemala and Aid flow (current US$) of Sudan?
Provide a succinct answer. -6.02e+07. In the year 1989, what is the difference between the Aid flow (current US$) in Cuba and Aid flow (current US$) in Grenada?
Provide a short and direct response. -9.00e+04. In the year 1989, what is the difference between the Aid flow (current US$) in Cuba and Aid flow (current US$) in Guatemala?
Provide a short and direct response. -7.31e+06. In the year 1989, what is the difference between the Aid flow (current US$) of Cuba and Aid flow (current US$) of Sudan?
Provide a succinct answer. -5.73e+07. In the year 1989, what is the difference between the Aid flow (current US$) in Grenada and Aid flow (current US$) in Guatemala?
Keep it short and to the point. -7.22e+06. In the year 1989, what is the difference between the Aid flow (current US$) of Grenada and Aid flow (current US$) of Sudan?
Provide a short and direct response. -5.72e+07. In the year 1989, what is the difference between the Aid flow (current US$) of Guatemala and Aid flow (current US$) of Sudan?
Your answer should be compact. -5.00e+07. In the year 1990, what is the difference between the Aid flow (current US$) of Cuba and Aid flow (current US$) of Guatemala?
Make the answer very short. -1.11e+07. In the year 1990, what is the difference between the Aid flow (current US$) of Cuba and Aid flow (current US$) of Sudan?
Your response must be concise. -6.25e+07. In the year 1990, what is the difference between the Aid flow (current US$) of Grenada and Aid flow (current US$) of Guatemala?
Your response must be concise. -1.09e+07. In the year 1990, what is the difference between the Aid flow (current US$) in Grenada and Aid flow (current US$) in Sudan?
Give a very brief answer. -6.23e+07. In the year 1990, what is the difference between the Aid flow (current US$) of Guatemala and Aid flow (current US$) of Sudan?
Your response must be concise. -5.14e+07. In the year 1991, what is the difference between the Aid flow (current US$) in Cuba and Aid flow (current US$) in Grenada?
Provide a succinct answer. -1.10e+05. In the year 1991, what is the difference between the Aid flow (current US$) of Cuba and Aid flow (current US$) of Guatemala?
Ensure brevity in your answer.  -7.09e+06. In the year 1991, what is the difference between the Aid flow (current US$) of Cuba and Aid flow (current US$) of Sudan?
Your answer should be very brief. -4.61e+07. In the year 1991, what is the difference between the Aid flow (current US$) of Grenada and Aid flow (current US$) of Guatemala?
Make the answer very short. -6.98e+06. In the year 1991, what is the difference between the Aid flow (current US$) in Grenada and Aid flow (current US$) in Sudan?
Offer a terse response. -4.60e+07. In the year 1991, what is the difference between the Aid flow (current US$) in Guatemala and Aid flow (current US$) in Sudan?
Your response must be concise. -3.90e+07. In the year 1993, what is the difference between the Aid flow (current US$) of Cuba and Aid flow (current US$) of Guatemala?
Make the answer very short. -1.18e+07. In the year 1993, what is the difference between the Aid flow (current US$) in Cuba and Aid flow (current US$) in Sudan?
Give a very brief answer. -3.52e+07. In the year 1993, what is the difference between the Aid flow (current US$) of Grenada and Aid flow (current US$) of Guatemala?
Make the answer very short. -1.16e+07. In the year 1993, what is the difference between the Aid flow (current US$) of Grenada and Aid flow (current US$) of Sudan?
Your response must be concise. -3.50e+07. In the year 1993, what is the difference between the Aid flow (current US$) of Guatemala and Aid flow (current US$) of Sudan?
Offer a very short reply. -2.34e+07. What is the ratio of the Aid flow (current US$) in Grenada in 1985 to that in 1986?
Provide a succinct answer. 0.62. What is the ratio of the Aid flow (current US$) in Sudan in 1985 to that in 1986?
Offer a very short reply. 0.53. What is the ratio of the Aid flow (current US$) in Cuba in 1985 to that in 1987?
Keep it short and to the point. 0.04. What is the ratio of the Aid flow (current US$) in Grenada in 1985 to that in 1987?
Offer a very short reply. 0.45. What is the ratio of the Aid flow (current US$) of Guatemala in 1985 to that in 1987?
Your response must be concise. 0.75. What is the ratio of the Aid flow (current US$) of Sudan in 1985 to that in 1987?
Your response must be concise. 0.47. What is the ratio of the Aid flow (current US$) in Cuba in 1985 to that in 1988?
Your response must be concise. 0.38. What is the ratio of the Aid flow (current US$) of Grenada in 1985 to that in 1988?
Offer a terse response. 0.42. What is the ratio of the Aid flow (current US$) in Guatemala in 1985 to that in 1988?
Your response must be concise. 0.29. What is the ratio of the Aid flow (current US$) of Sudan in 1985 to that in 1988?
Offer a very short reply. 0.41. What is the ratio of the Aid flow (current US$) in Grenada in 1985 to that in 1989?
Keep it short and to the point. 0.45. What is the ratio of the Aid flow (current US$) in Guatemala in 1985 to that in 1989?
Give a very brief answer. 0.26. What is the ratio of the Aid flow (current US$) of Sudan in 1985 to that in 1989?
Give a very brief answer. 0.48. What is the ratio of the Aid flow (current US$) of Cuba in 1985 to that in 1990?
Your answer should be compact. 3. What is the ratio of the Aid flow (current US$) in Grenada in 1985 to that in 1990?
Your answer should be compact. 0.22. What is the ratio of the Aid flow (current US$) in Guatemala in 1985 to that in 1990?
Keep it short and to the point. 0.17. What is the ratio of the Aid flow (current US$) of Sudan in 1985 to that in 1990?
Make the answer very short. 0.44. What is the ratio of the Aid flow (current US$) of Cuba in 1985 to that in 1991?
Your response must be concise. 0.14. What is the ratio of the Aid flow (current US$) in Grenada in 1985 to that in 1991?
Offer a very short reply. 0.15. What is the ratio of the Aid flow (current US$) in Guatemala in 1985 to that in 1991?
Keep it short and to the point. 0.27. What is the ratio of the Aid flow (current US$) of Sudan in 1985 to that in 1991?
Offer a very short reply. 0.6. What is the ratio of the Aid flow (current US$) of Cuba in 1985 to that in 1993?
Provide a succinct answer. 0.27. What is the ratio of the Aid flow (current US$) in Guatemala in 1985 to that in 1993?
Provide a short and direct response. 0.16. What is the ratio of the Aid flow (current US$) in Sudan in 1985 to that in 1993?
Keep it short and to the point. 0.79. What is the ratio of the Aid flow (current US$) in Grenada in 1986 to that in 1987?
Make the answer very short. 0.73. What is the ratio of the Aid flow (current US$) in Guatemala in 1986 to that in 1987?
Provide a succinct answer. 0.76. What is the ratio of the Aid flow (current US$) of Sudan in 1986 to that in 1987?
Offer a very short reply. 0.89. What is the ratio of the Aid flow (current US$) of Guatemala in 1986 to that in 1988?
Your response must be concise. 0.29. What is the ratio of the Aid flow (current US$) in Sudan in 1986 to that in 1988?
Ensure brevity in your answer.  0.78. What is the ratio of the Aid flow (current US$) of Grenada in 1986 to that in 1989?
Your answer should be very brief. 0.73. What is the ratio of the Aid flow (current US$) of Guatemala in 1986 to that in 1989?
Give a very brief answer. 0.27. What is the ratio of the Aid flow (current US$) of Sudan in 1986 to that in 1989?
Offer a terse response. 0.92. What is the ratio of the Aid flow (current US$) in Grenada in 1986 to that in 1990?
Offer a terse response. 0.35. What is the ratio of the Aid flow (current US$) in Guatemala in 1986 to that in 1990?
Make the answer very short. 0.18. What is the ratio of the Aid flow (current US$) of Sudan in 1986 to that in 1990?
Provide a succinct answer. 0.84. What is the ratio of the Aid flow (current US$) in Grenada in 1986 to that in 1991?
Make the answer very short. 0.24. What is the ratio of the Aid flow (current US$) in Guatemala in 1986 to that in 1991?
Keep it short and to the point. 0.27. What is the ratio of the Aid flow (current US$) of Sudan in 1986 to that in 1991?
Ensure brevity in your answer.  1.13. What is the ratio of the Aid flow (current US$) in Grenada in 1986 to that in 1993?
Your answer should be very brief. 0.27. What is the ratio of the Aid flow (current US$) of Guatemala in 1986 to that in 1993?
Make the answer very short. 0.16. What is the ratio of the Aid flow (current US$) of Sudan in 1986 to that in 1993?
Provide a short and direct response. 1.49. What is the ratio of the Aid flow (current US$) in Cuba in 1987 to that in 1988?
Keep it short and to the point. 8.62. What is the ratio of the Aid flow (current US$) in Grenada in 1987 to that in 1988?
Your answer should be very brief. 0.92. What is the ratio of the Aid flow (current US$) of Guatemala in 1987 to that in 1988?
Your answer should be compact. 0.38. What is the ratio of the Aid flow (current US$) of Sudan in 1987 to that in 1988?
Make the answer very short. 0.88. What is the ratio of the Aid flow (current US$) of Cuba in 1987 to that in 1989?
Keep it short and to the point. 34.5. What is the ratio of the Aid flow (current US$) of Grenada in 1987 to that in 1989?
Offer a very short reply. 1. What is the ratio of the Aid flow (current US$) in Guatemala in 1987 to that in 1989?
Your answer should be very brief. 0.35. What is the ratio of the Aid flow (current US$) in Sudan in 1987 to that in 1989?
Make the answer very short. 1.03. What is the ratio of the Aid flow (current US$) of Cuba in 1987 to that in 1990?
Offer a terse response. 69. What is the ratio of the Aid flow (current US$) in Grenada in 1987 to that in 1990?
Your response must be concise. 0.48. What is the ratio of the Aid flow (current US$) in Guatemala in 1987 to that in 1990?
Offer a very short reply. 0.23. What is the ratio of the Aid flow (current US$) of Sudan in 1987 to that in 1990?
Give a very brief answer. 0.94. What is the ratio of the Aid flow (current US$) in Cuba in 1987 to that in 1991?
Keep it short and to the point. 3.14. What is the ratio of the Aid flow (current US$) of Grenada in 1987 to that in 1991?
Keep it short and to the point. 0.33. What is the ratio of the Aid flow (current US$) in Guatemala in 1987 to that in 1991?
Provide a succinct answer. 0.35. What is the ratio of the Aid flow (current US$) in Sudan in 1987 to that in 1991?
Provide a short and direct response. 1.27. What is the ratio of the Aid flow (current US$) in Cuba in 1987 to that in 1993?
Provide a succinct answer. 6.27. What is the ratio of the Aid flow (current US$) in Grenada in 1987 to that in 1993?
Your response must be concise. 0.37. What is the ratio of the Aid flow (current US$) in Guatemala in 1987 to that in 1993?
Ensure brevity in your answer.  0.22. What is the ratio of the Aid flow (current US$) in Sudan in 1987 to that in 1993?
Your answer should be compact. 1.67. What is the ratio of the Aid flow (current US$) in Guatemala in 1988 to that in 1989?
Offer a terse response. 0.92. What is the ratio of the Aid flow (current US$) of Sudan in 1988 to that in 1989?
Provide a short and direct response. 1.17. What is the ratio of the Aid flow (current US$) in Cuba in 1988 to that in 1990?
Offer a terse response. 8. What is the ratio of the Aid flow (current US$) of Grenada in 1988 to that in 1990?
Provide a succinct answer. 0.52. What is the ratio of the Aid flow (current US$) in Guatemala in 1988 to that in 1990?
Give a very brief answer. 0.61. What is the ratio of the Aid flow (current US$) of Sudan in 1988 to that in 1990?
Keep it short and to the point. 1.07. What is the ratio of the Aid flow (current US$) of Cuba in 1988 to that in 1991?
Offer a terse response. 0.36. What is the ratio of the Aid flow (current US$) in Grenada in 1988 to that in 1991?
Your response must be concise. 0.36. What is the ratio of the Aid flow (current US$) in Guatemala in 1988 to that in 1991?
Keep it short and to the point. 0.92. What is the ratio of the Aid flow (current US$) of Sudan in 1988 to that in 1991?
Offer a very short reply. 1.45. What is the ratio of the Aid flow (current US$) in Cuba in 1988 to that in 1993?
Ensure brevity in your answer.  0.73. What is the ratio of the Aid flow (current US$) of Guatemala in 1988 to that in 1993?
Your answer should be very brief. 0.57. What is the ratio of the Aid flow (current US$) in Sudan in 1988 to that in 1993?
Your answer should be compact. 1.9. What is the ratio of the Aid flow (current US$) in Grenada in 1989 to that in 1990?
Provide a succinct answer. 0.48. What is the ratio of the Aid flow (current US$) of Guatemala in 1989 to that in 1990?
Offer a terse response. 0.66. What is the ratio of the Aid flow (current US$) of Sudan in 1989 to that in 1990?
Your answer should be very brief. 0.92. What is the ratio of the Aid flow (current US$) in Cuba in 1989 to that in 1991?
Offer a very short reply. 0.09. What is the ratio of the Aid flow (current US$) in Grenada in 1989 to that in 1991?
Keep it short and to the point. 0.33. What is the ratio of the Aid flow (current US$) of Sudan in 1989 to that in 1991?
Your answer should be compact. 1.24. What is the ratio of the Aid flow (current US$) of Cuba in 1989 to that in 1993?
Offer a very short reply. 0.18. What is the ratio of the Aid flow (current US$) of Grenada in 1989 to that in 1993?
Ensure brevity in your answer.  0.37. What is the ratio of the Aid flow (current US$) of Guatemala in 1989 to that in 1993?
Offer a terse response. 0.62. What is the ratio of the Aid flow (current US$) of Sudan in 1989 to that in 1993?
Your response must be concise. 1.62. What is the ratio of the Aid flow (current US$) of Cuba in 1990 to that in 1991?
Offer a very short reply. 0.05. What is the ratio of the Aid flow (current US$) in Grenada in 1990 to that in 1991?
Offer a terse response. 0.7. What is the ratio of the Aid flow (current US$) in Guatemala in 1990 to that in 1991?
Make the answer very short. 1.52. What is the ratio of the Aid flow (current US$) of Sudan in 1990 to that in 1991?
Provide a short and direct response. 1.35. What is the ratio of the Aid flow (current US$) in Cuba in 1990 to that in 1993?
Offer a terse response. 0.09. What is the ratio of the Aid flow (current US$) of Grenada in 1990 to that in 1993?
Your response must be concise. 0.77. What is the ratio of the Aid flow (current US$) of Guatemala in 1990 to that in 1993?
Your answer should be compact. 0.93. What is the ratio of the Aid flow (current US$) of Sudan in 1990 to that in 1993?
Your response must be concise. 1.77. What is the ratio of the Aid flow (current US$) of Guatemala in 1991 to that in 1993?
Offer a terse response. 0.61. What is the ratio of the Aid flow (current US$) in Sudan in 1991 to that in 1993?
Make the answer very short. 1.31. What is the difference between the highest and the second highest Aid flow (current US$) in Cuba?
Your response must be concise. 4.70e+05. What is the difference between the highest and the second highest Aid flow (current US$) of Sudan?
Ensure brevity in your answer.  4.47e+06. What is the difference between the highest and the lowest Aid flow (current US$) in Cuba?
Ensure brevity in your answer.  6.90e+05. What is the difference between the highest and the lowest Aid flow (current US$) of Guatemala?
Make the answer very short. 9.95e+06. What is the difference between the highest and the lowest Aid flow (current US$) of Sudan?
Your answer should be very brief. 3.92e+07. 